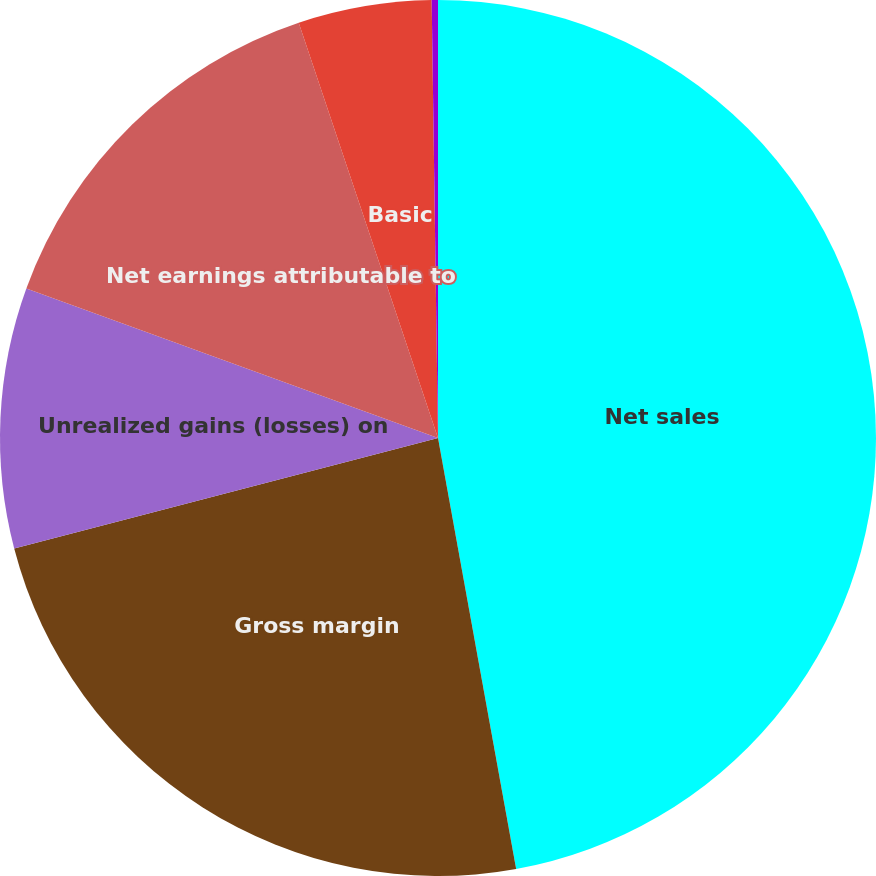<chart> <loc_0><loc_0><loc_500><loc_500><pie_chart><fcel>Net sales<fcel>Gross margin<fcel>Unrealized gains (losses) on<fcel>Net earnings attributable to<fcel>Basic<fcel>Diluted<nl><fcel>47.14%<fcel>23.79%<fcel>9.61%<fcel>14.3%<fcel>4.92%<fcel>0.23%<nl></chart> 